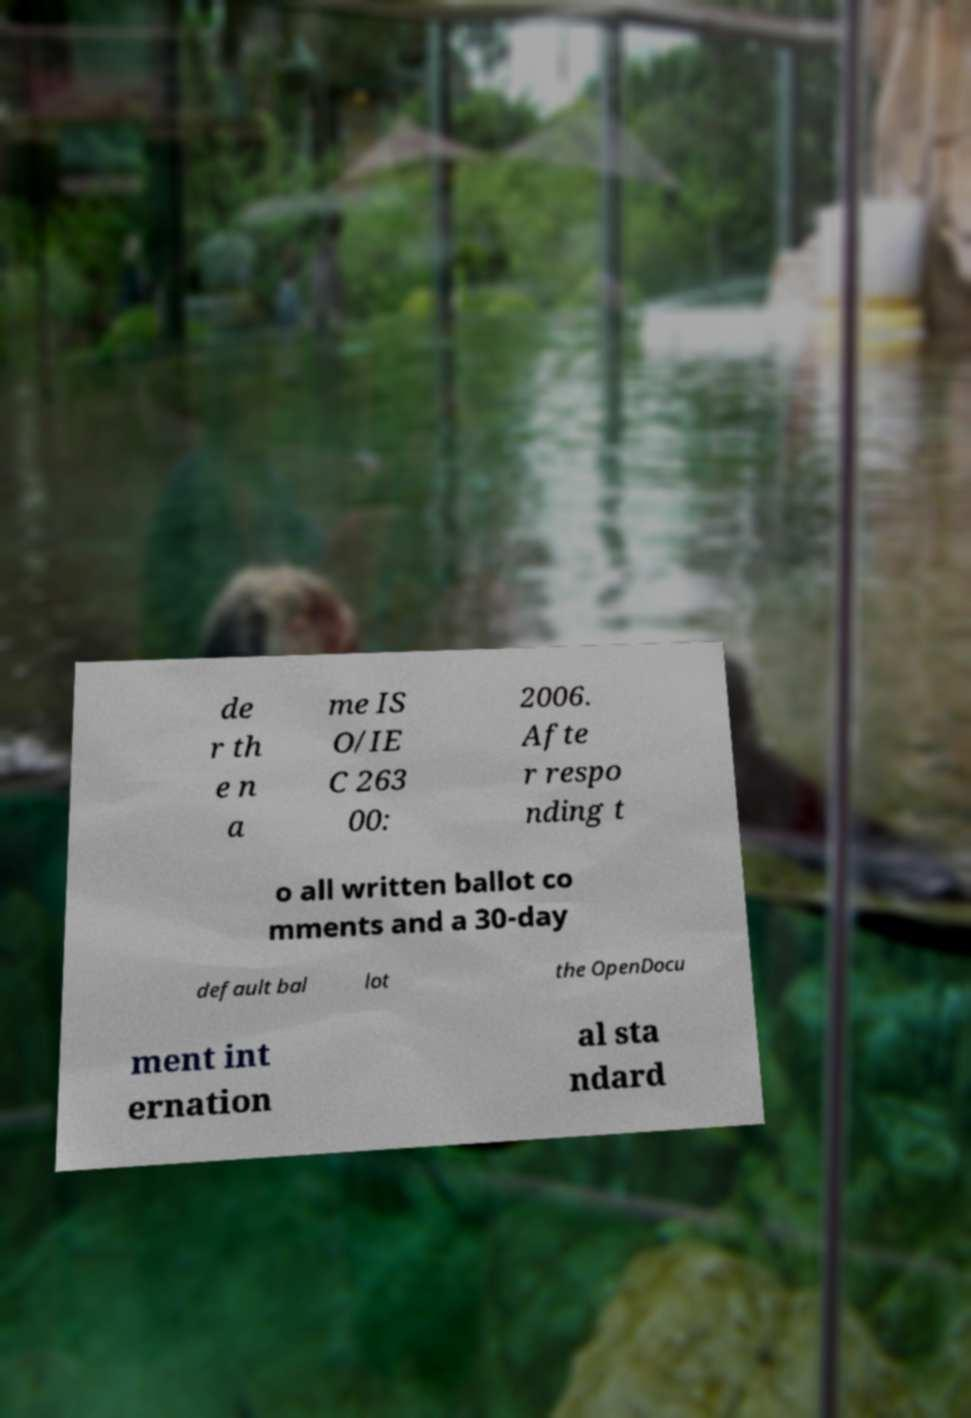Could you assist in decoding the text presented in this image and type it out clearly? de r th e n a me IS O/IE C 263 00: 2006. Afte r respo nding t o all written ballot co mments and a 30-day default bal lot the OpenDocu ment int ernation al sta ndard 